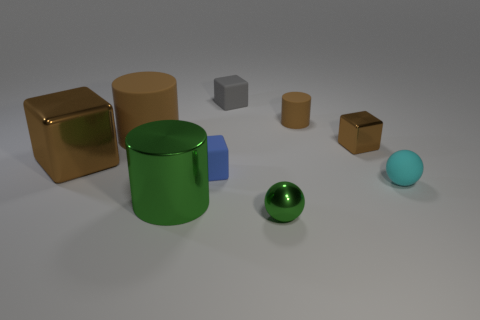Are there any brown cubes?
Give a very brief answer. Yes. Are there more tiny cubes behind the small blue object than things to the right of the big green metallic thing?
Ensure brevity in your answer.  No. There is another cylinder that is made of the same material as the tiny brown cylinder; what size is it?
Give a very brief answer. Large. What is the size of the cylinder that is in front of the brown thing that is in front of the brown cube behind the big metallic cube?
Provide a short and direct response. Large. What is the color of the cube to the right of the small gray rubber cube?
Offer a very short reply. Brown. Are there more rubber cylinders that are behind the metal cylinder than blue things?
Your answer should be very brief. Yes. There is a big brown object that is in front of the small brown metal object; does it have the same shape as the small blue rubber object?
Provide a succinct answer. Yes. How many green objects are either tiny cubes or tiny matte spheres?
Provide a short and direct response. 0. Are there more large red blocks than large brown cubes?
Offer a very short reply. No. There is a metallic object that is the same size as the metal cylinder; what is its color?
Your answer should be very brief. Brown. 